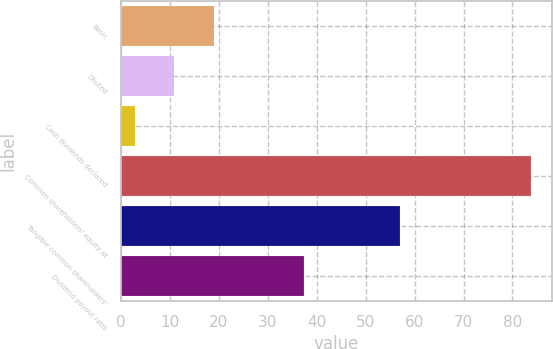<chart> <loc_0><loc_0><loc_500><loc_500><bar_chart><fcel>Basic<fcel>Diluted<fcel>Cash dividends declared<fcel>Common shareholders' equity at<fcel>Tangible common shareholders'<fcel>Dividend payout ratio<nl><fcel>19.02<fcel>10.91<fcel>2.8<fcel>83.88<fcel>57.06<fcel>37.49<nl></chart> 